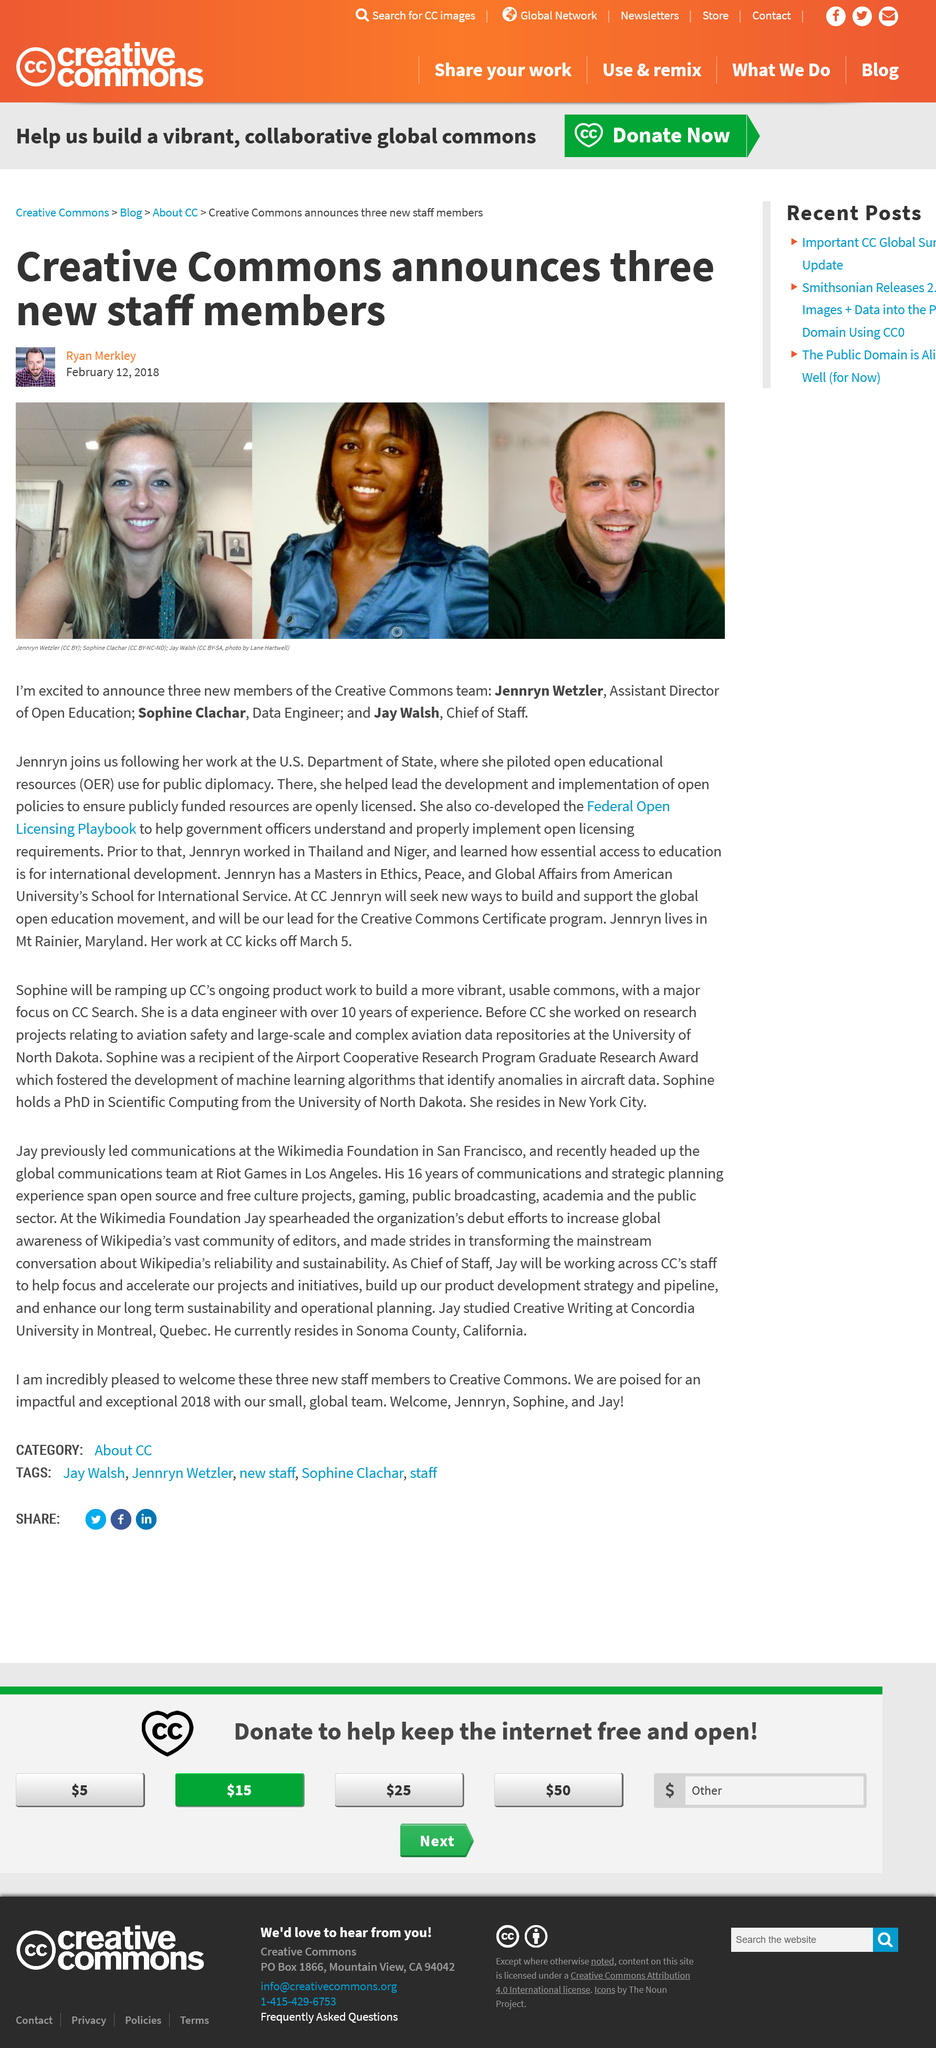Draw attention to some important aspects in this diagram. Jennryn Wetzler holds a Master's degree in Ethics, Peace, and Global Affairs from the American University's School for International Service. Sophine Clachar became the Data Engineer of the Creative Commons in 2018. The third person in the main image is Jay Walsh. 